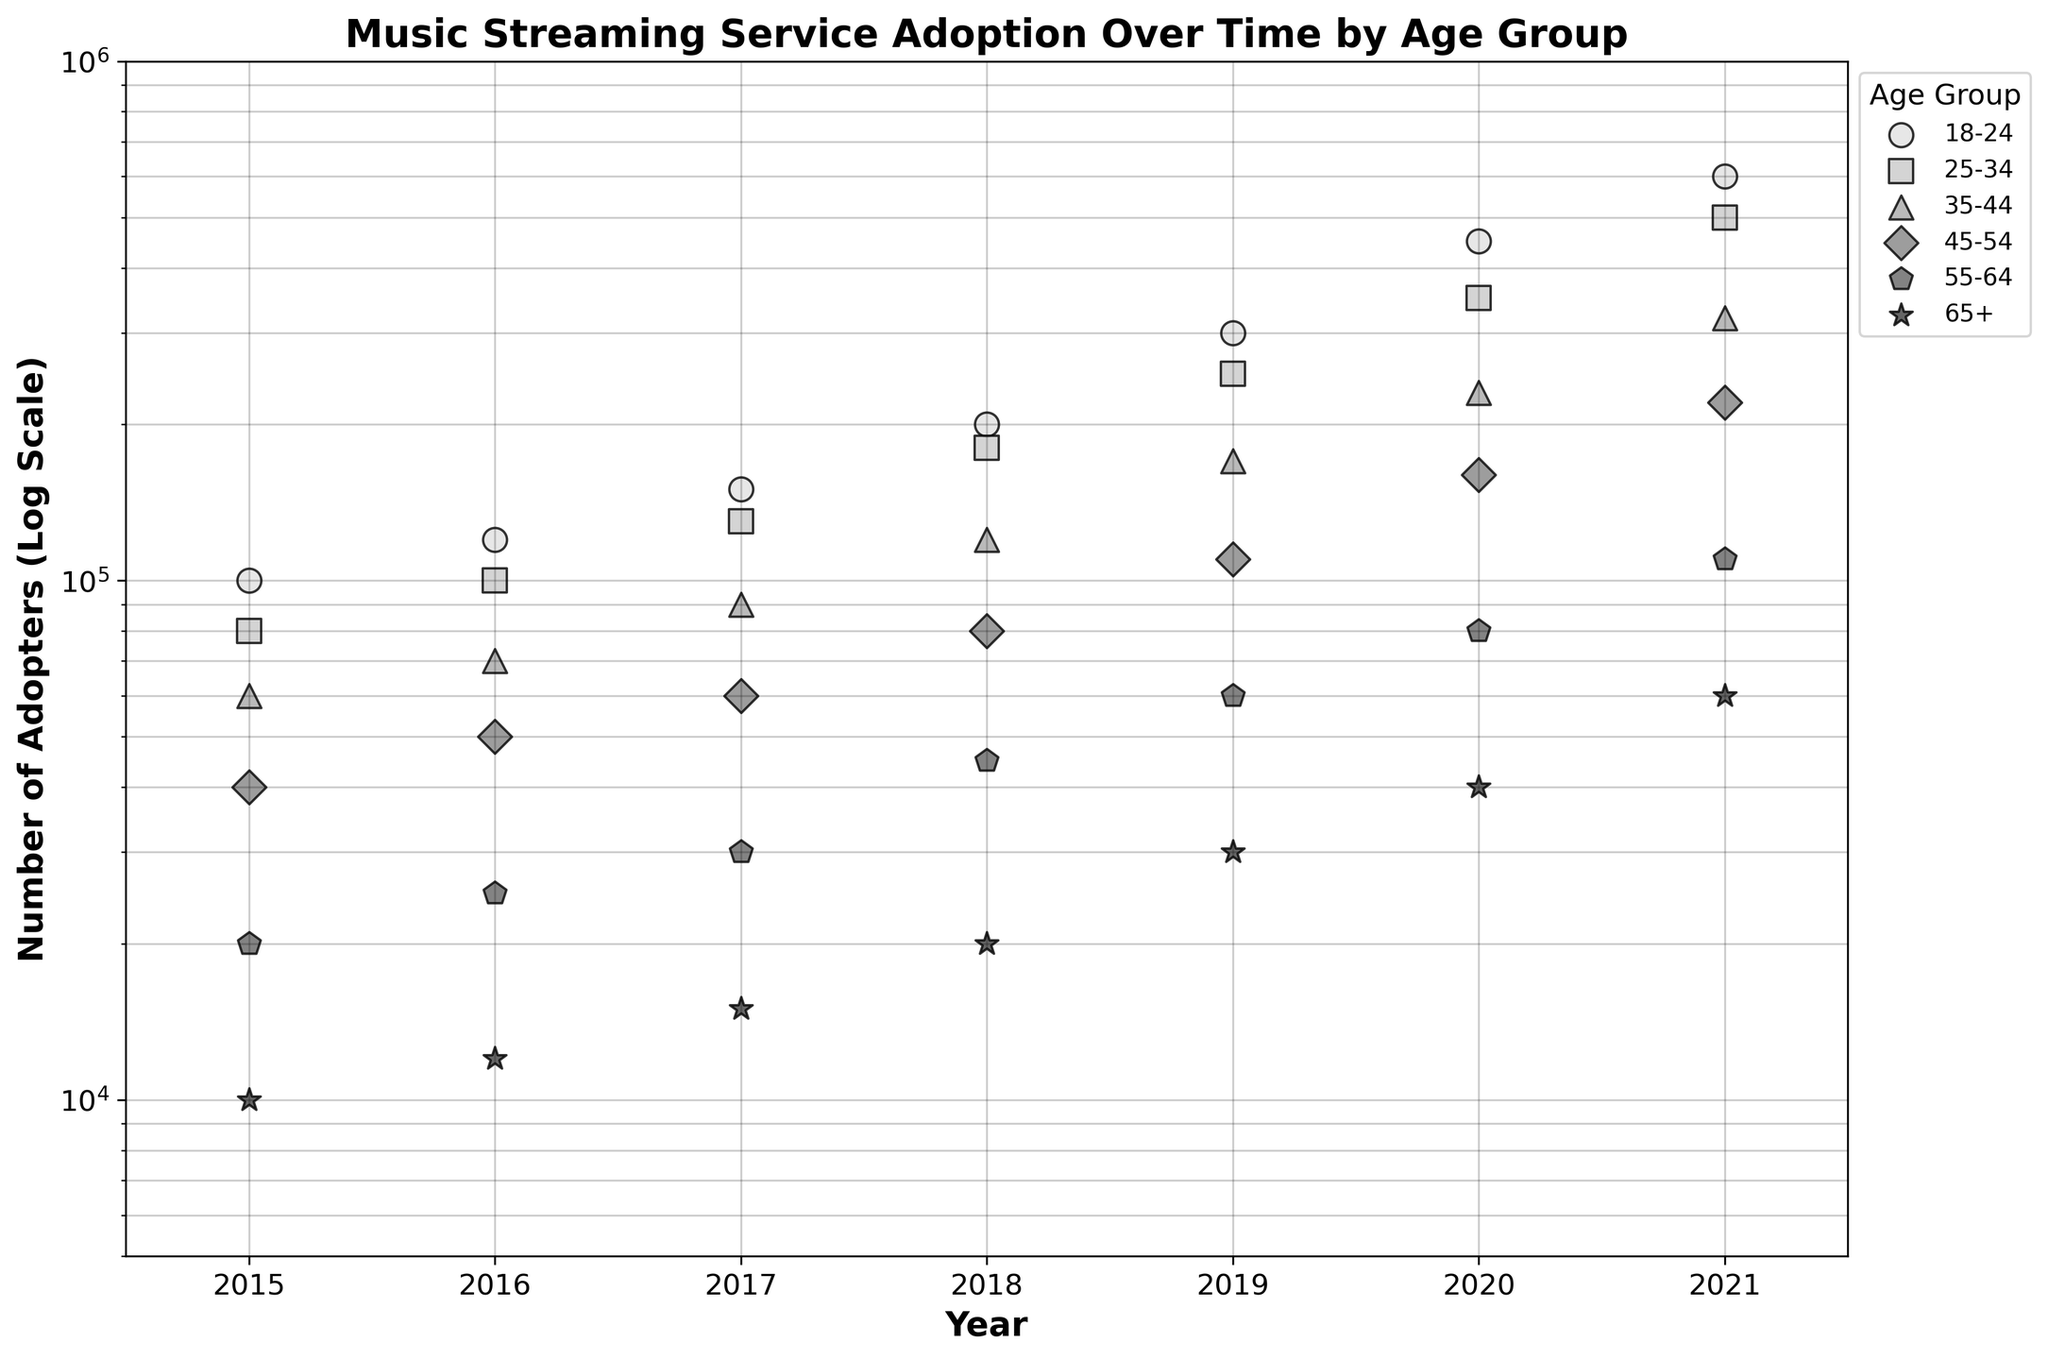what is the title of the figure? The title is usually found at the top of the plot and provides a summary of what the plot is about.
Answer: Music Streaming Service Adoption Over Time by Age Group What is the y-axis scale on the plot? The y-axis scale can be identified by looking at the axis label, which in this case mentions the type of scale used.
Answer: Logarithmic (Log) Which age group has the highest number of adopters in 2021? By looking at the data points for 2021 on the right side of the x-axis and identifying the highest point, the age group with the highest number of adopters can be determined.
Answer: 18-24 What is the smallest number of adopters recorded, and in which age group and year did it occur? Identify the smallest y-axis value among all the points and note the corresponding age group and year from the x-axis labels.
Answer: 10,000 in age group 65+ in 2015 How has the number of adopters in the 25-34 age group changed from 2015 to 2021? Locate the trend line or points for the group "25-34" and compare the values at 2015 and 2021. Observe the trend direction, whether it is increasing, decreasing, or stagnant.
Answer: Increased Which age group shows the sharpest increase in the number of adopters over the years? Compare the slopes of the trend lines or the relative increase in the number of adopters for each age group from 2015 to 2021.
Answer: 18-24 What is the approximate average number of adopters in 2021 across all age groups? Note the y-values for each age group in 2021, sum them up, and divide by the number of age groups. The average can be calculated manually or visually approximated.
Answer: Approximately 408,000 Which two age groups show a parallel trend in the increase of adopters from 2015 to 2021? Look at the trend lines or scatter points for each age group and compare their slopes. Parallel trends indicate similar growth patterns.
Answer: 18-24 and 25-34 What is the range of adopters for the 55-64 age group over the years? Note the highest and lowest y-values for the 55-64 age group and calculate the difference between these two values.
Answer: 90,000 (110,000 - 20,000) Does the number of adopters for the 35-44 age group exceed 100,000 at any point? Identify the y-values for the 35-44 age group and check if any of them exceed 100,000.
Answer: Yes 